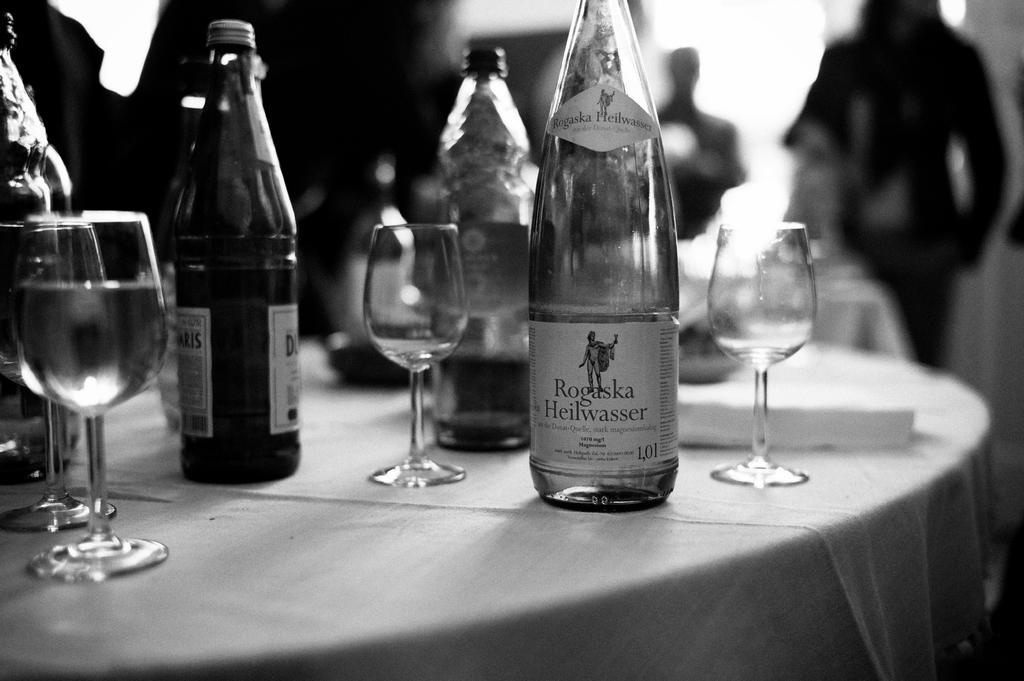Could you give a brief overview of what you see in this image? Bottom left side of the image there is a table on the table there is a cloth and glasses and bottles. Top right side of the image there is a person standing. 